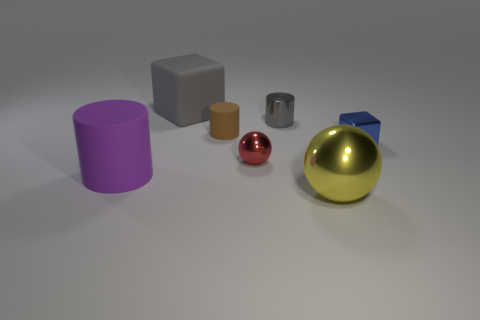Subtract all tiny cylinders. How many cylinders are left? 1 Add 2 big yellow cubes. How many objects exist? 9 Subtract all yellow spheres. How many spheres are left? 1 Subtract 2 cylinders. How many cylinders are left? 1 Add 6 large blue objects. How many large blue objects exist? 6 Subtract 0 blue cylinders. How many objects are left? 7 Subtract all spheres. How many objects are left? 5 Subtract all blue balls. Subtract all gray cylinders. How many balls are left? 2 Subtract all red cylinders. How many green cubes are left? 0 Subtract all metallic objects. Subtract all large brown cylinders. How many objects are left? 3 